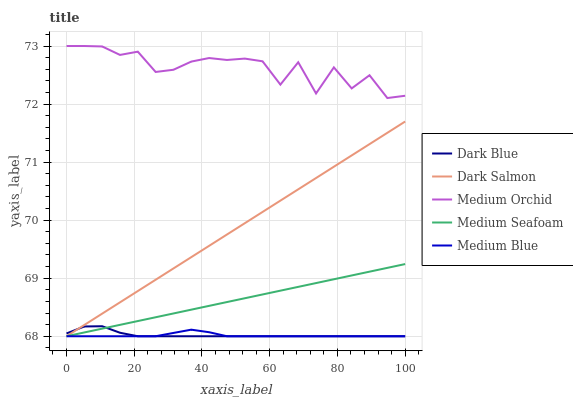Does Medium Blue have the minimum area under the curve?
Answer yes or no. Yes. Does Medium Orchid have the maximum area under the curve?
Answer yes or no. Yes. Does Medium Orchid have the minimum area under the curve?
Answer yes or no. No. Does Medium Blue have the maximum area under the curve?
Answer yes or no. No. Is Medium Seafoam the smoothest?
Answer yes or no. Yes. Is Medium Orchid the roughest?
Answer yes or no. Yes. Is Medium Blue the smoothest?
Answer yes or no. No. Is Medium Blue the roughest?
Answer yes or no. No. Does Medium Orchid have the lowest value?
Answer yes or no. No. Does Medium Orchid have the highest value?
Answer yes or no. Yes. Does Medium Blue have the highest value?
Answer yes or no. No. Is Medium Seafoam less than Medium Orchid?
Answer yes or no. Yes. Is Medium Orchid greater than Medium Blue?
Answer yes or no. Yes. Does Dark Salmon intersect Medium Seafoam?
Answer yes or no. Yes. Is Dark Salmon less than Medium Seafoam?
Answer yes or no. No. Is Dark Salmon greater than Medium Seafoam?
Answer yes or no. No. Does Medium Seafoam intersect Medium Orchid?
Answer yes or no. No. 